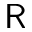Convert formula to latex. <formula><loc_0><loc_0><loc_500><loc_500>R</formula> 